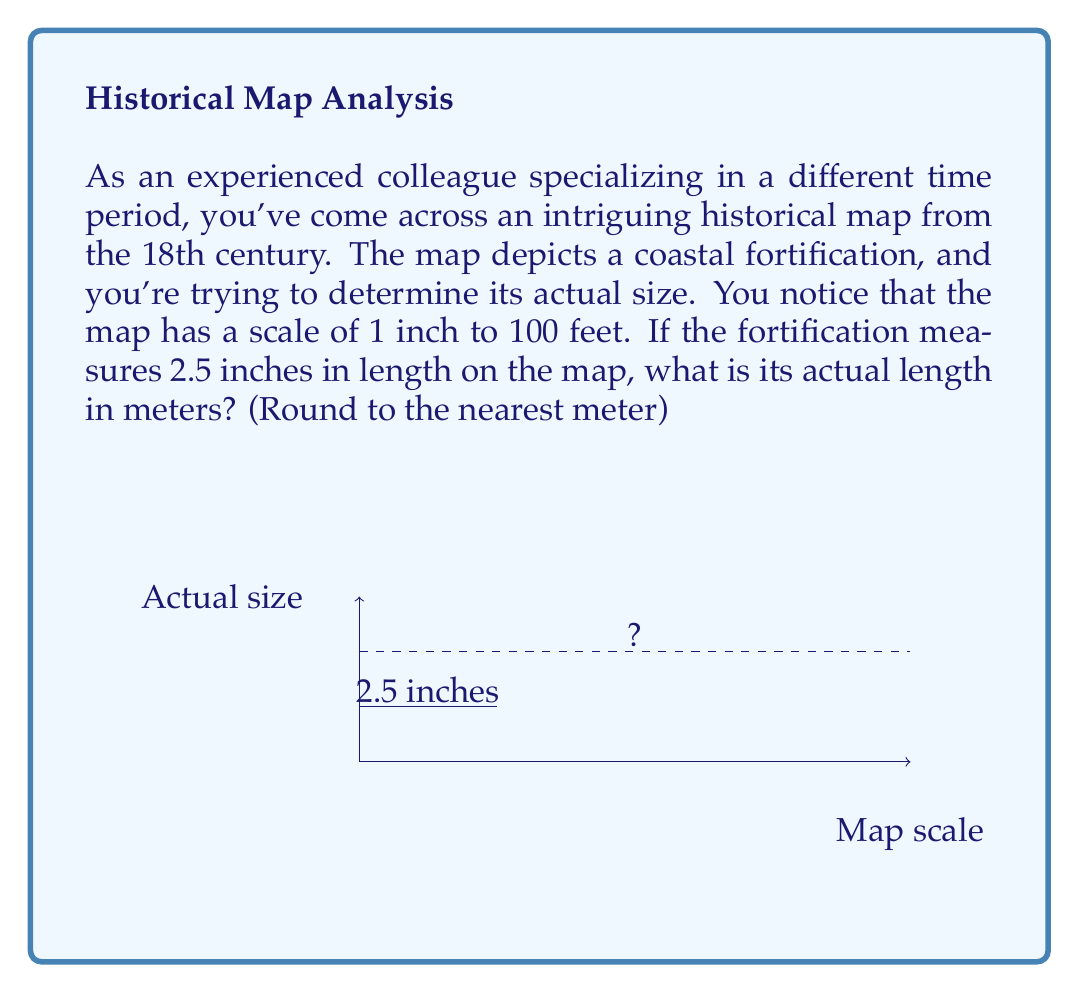What is the answer to this math problem? Let's approach this step-by-step:

1) First, we need to understand the scale:
   1 inch on the map = 100 feet in reality

2) The fortification measures 2.5 inches on the map. So, we need to find out how many feet this represents:
   $2.5 \times 100 = 250$ feet

3) Now we need to convert feet to meters. The conversion factor is:
   1 foot ≈ 0.3048 meters

4) So, we can calculate the length in meters:
   $250 \times 0.3048 = 76.2$ meters

5) Rounding to the nearest meter:
   76.2 meters ≈ 76 meters

Therefore, the actual length of the fortification is approximately 76 meters.
Answer: 76 meters 